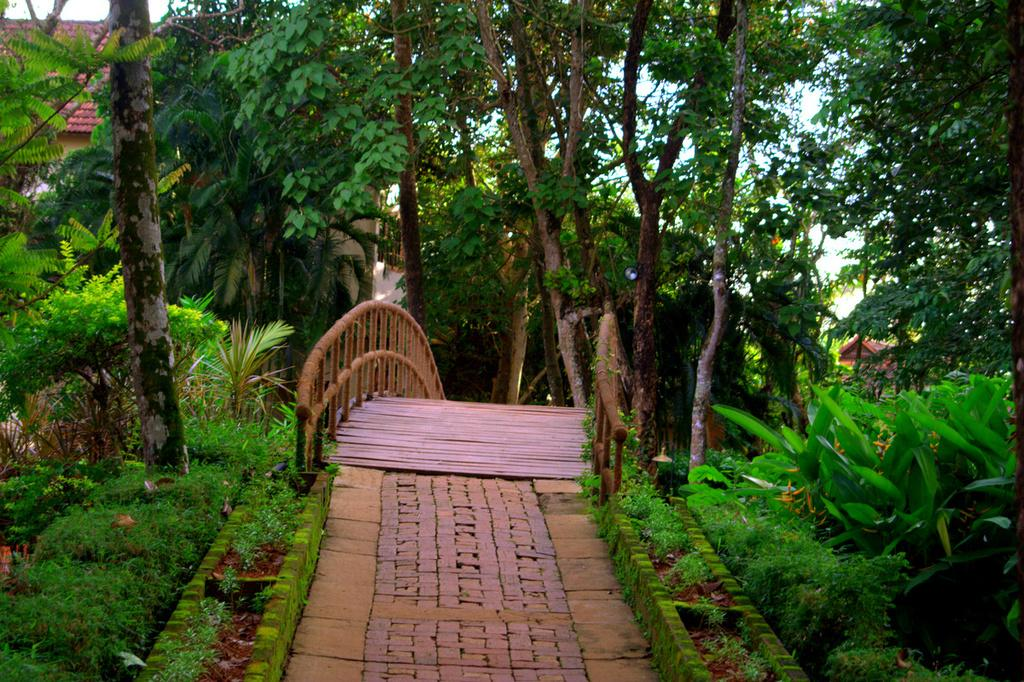What is the main structure in the center of the image? There is a wooden bridge in the center of the image. What type of natural environment is depicted in the image? There is greenery in the image. What can be seen in the background of the image? There are houses in the background of the image. How much net is used to catch fish in the image? There is no net present in the image, and therefore no fishing activity can be observed. 